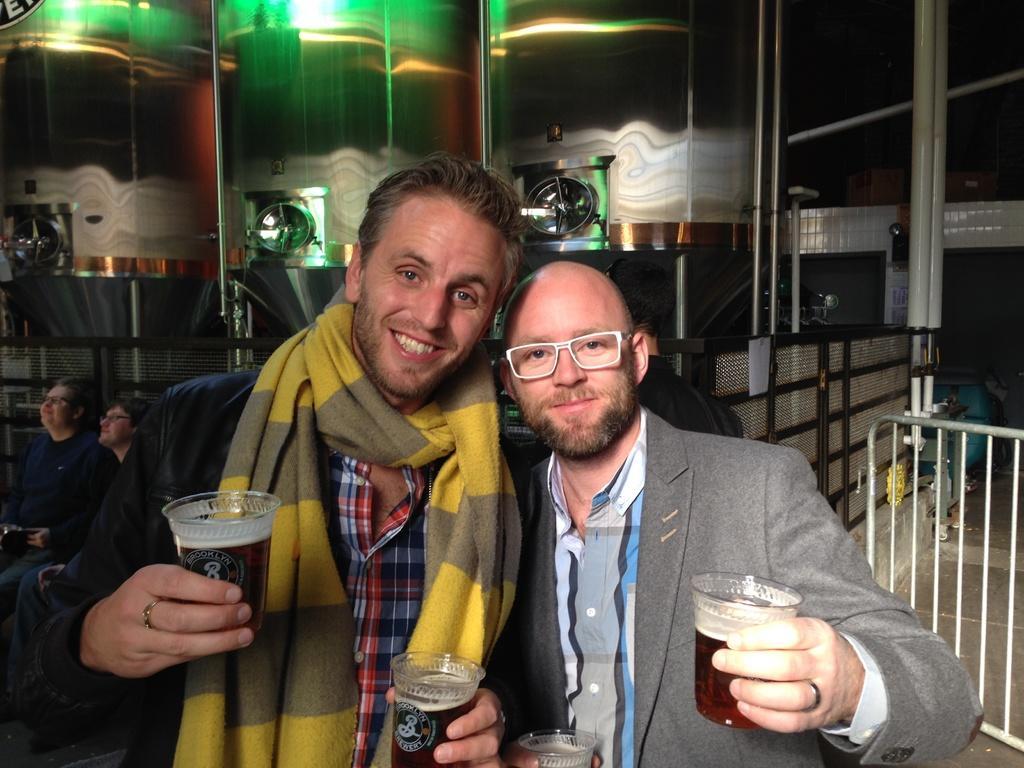In one or two sentences, can you explain what this image depicts? In this Image I see 2 men in front and both of them are holding the cups in their hands and they are smiling. In the background I see 2 persons who are sitting over here and I see the fence. 